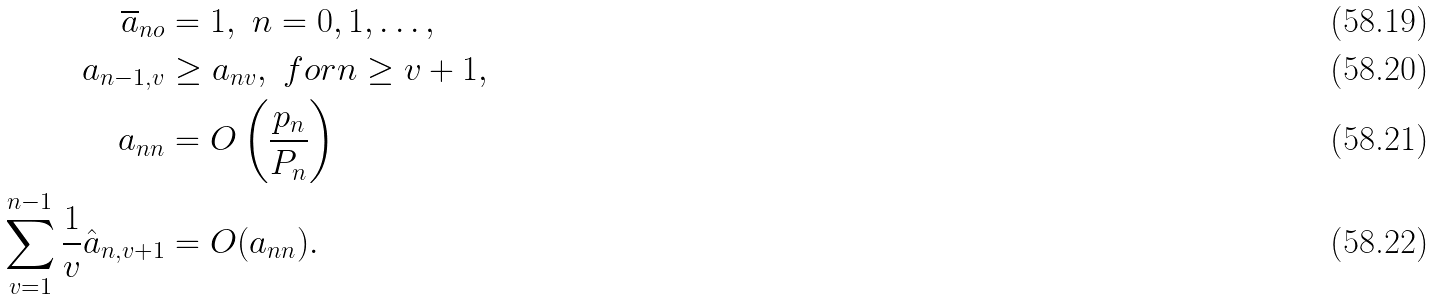<formula> <loc_0><loc_0><loc_500><loc_500>\overline { a } _ { n o } & = 1 , \ n = 0 , 1 , \dots , \\ a _ { n - 1 , v } & \geq a _ { n v } , \ f o r n \geq v + 1 , \\ a _ { n n } & = O \left ( \frac { p _ { n } } { P _ { n } } \right ) \\ \sum _ { v = 1 } ^ { n - 1 } \frac { 1 } { v } \hat { a } _ { n , v + 1 } & = O ( a _ { n n } ) .</formula> 